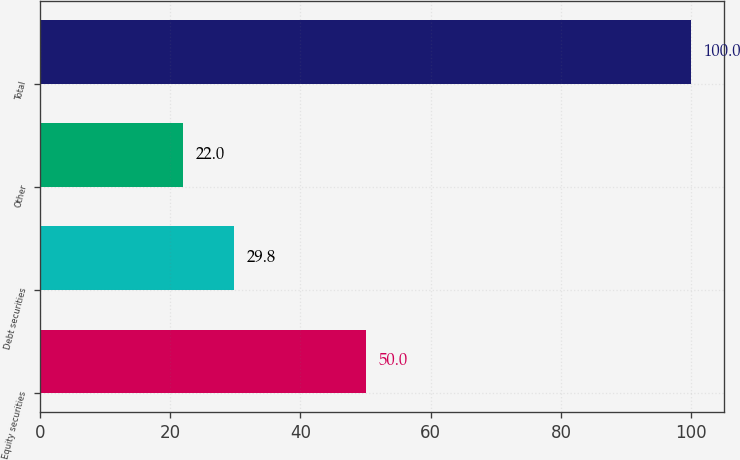Convert chart to OTSL. <chart><loc_0><loc_0><loc_500><loc_500><bar_chart><fcel>Equity securities<fcel>Debt securities<fcel>Other<fcel>Total<nl><fcel>50<fcel>29.8<fcel>22<fcel>100<nl></chart> 